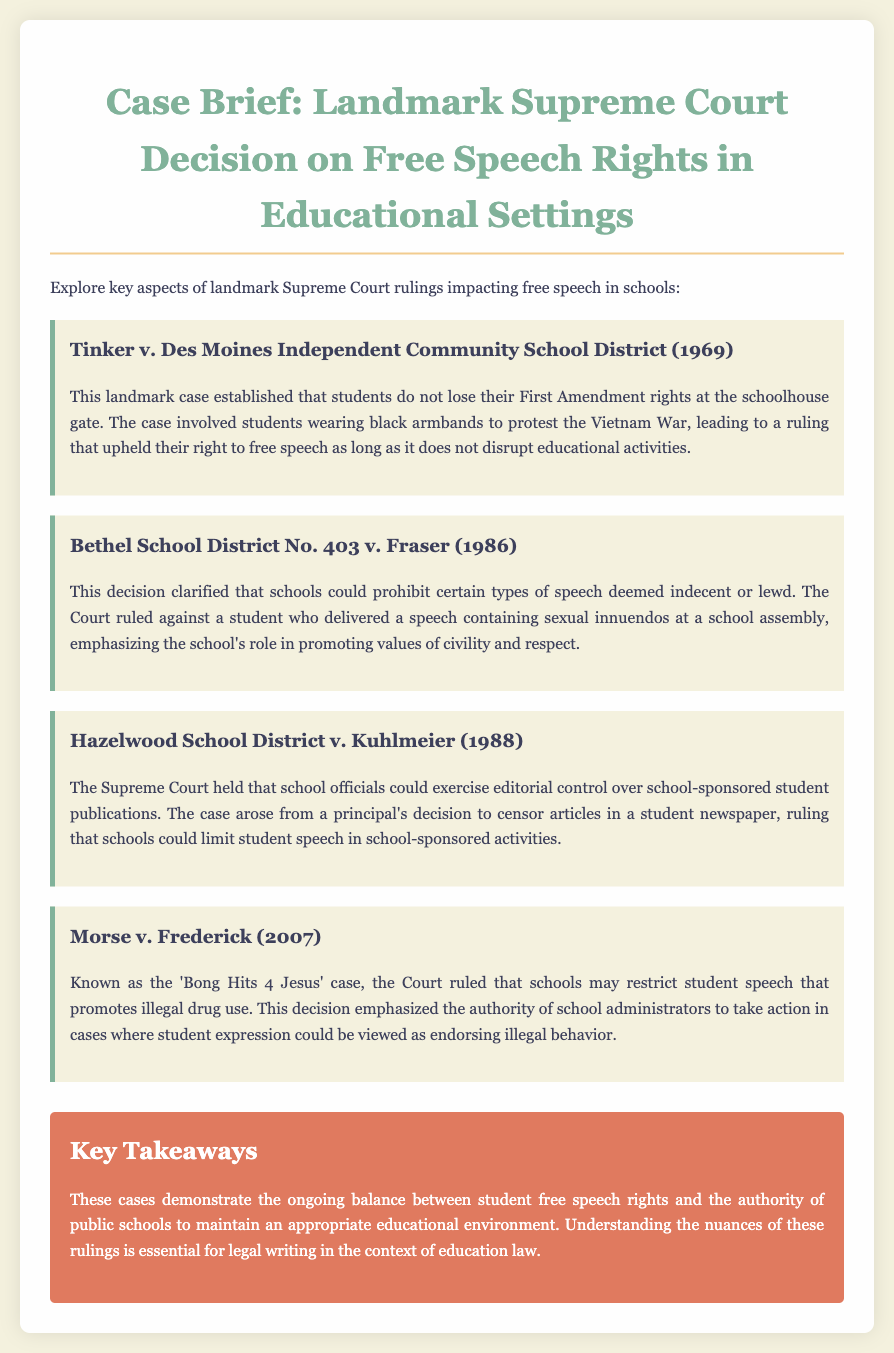What is the first landmark case discussed? The first case discussed is Tinker v. Des Moines Independent Community School District, which is a landmark case related to free speech rights.
Answer: Tinker v. Des Moines Independent Community School District What year was Tinker v. Des Moines decided? The case was decided in 1969, which is mentioned in the document.
Answer: 1969 What type of speech was prohibited in Bethel School District No. 403 v. Fraser? The case involved the prohibition of indecent or lewd speech, as clarified by the Court's ruling.
Answer: Indecent or lewd What was the key issue in Hazelwood School District v. Kuhlmeier? The key issue was the editorial control over school-sponsored student publications decided by the Supreme Court.
Answer: Editorial control Which case is known as the 'Bong Hits 4 Jesus' case? The case referred to as the 'Bong Hits 4 Jesus' case is Morse v. Frederick.
Answer: Morse v. Frederick How many landmark Supreme Court cases are discussed in this document? The document discusses a total of four landmark Supreme Court cases related to free speech rights.
Answer: Four What overarching theme do these cases represent? The cases collectively demonstrate the balance between student free speech rights and the authority of public schools.
Answer: Balance What do the key takeaways emphasize in the context of education law? The key takeaways emphasize the importance of understanding the nuances of the rulings in education law.
Answer: Nuances of the rulings 